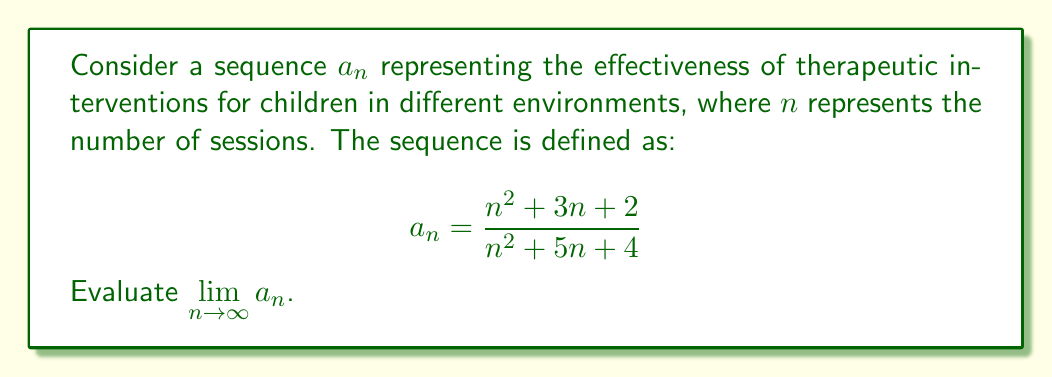Give your solution to this math problem. To evaluate this limit, we'll follow these steps:

1) First, let's examine the behavior of the numerator and denominator separately as $n$ approaches infinity.

2) For the numerator: $n^2 + 3n + 2$
   The highest degree term is $n^2$, so this grows quadratically.

3) For the denominator: $n^2 + 5n + 4$
   The highest degree term is also $n^2$, so this also grows quadratically.

4) When we have a ratio of two quadratic functions as $n$ approaches infinity, the limit will be the ratio of the coefficients of the highest degree terms.

5) In this case, both the numerator and denominator have $n^2$ as the highest degree term, and both have a coefficient of 1.

6) Therefore, we can evaluate the limit as follows:

   $$\lim_{n \to \infty} a_n = \lim_{n \to \infty} \frac{n^2 + 3n + 2}{n^2 + 5n + 4}$$
   
   $$= \lim_{n \to \infty} \frac{n^2(1 + \frac{3}{n} + \frac{2}{n^2})}{n^2(1 + \frac{5}{n} + \frac{4}{n^2})}$$
   
   $$= \frac{\lim_{n \to \infty} (1 + \frac{3}{n} + \frac{2}{n^2})}{\lim_{n \to \infty} (1 + \frac{5}{n} + \frac{4}{n^2})}$$
   
   $$= \frac{1 + 0 + 0}{1 + 0 + 0} = 1$$

7) This result suggests that as the number of therapeutic sessions increases, the effectiveness of the interventions in different environments converges to a stable value.
Answer: $\lim_{n \to \infty} a_n = 1$ 